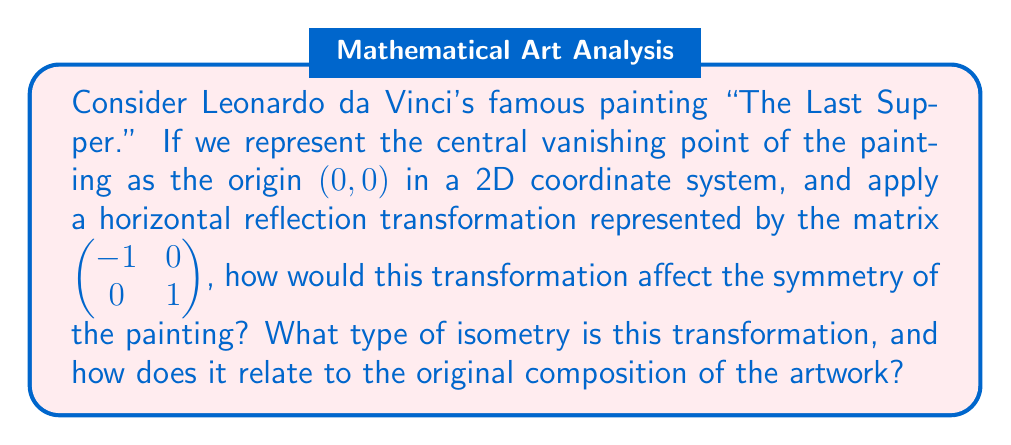Solve this math problem. To analyze this problem, let's break it down into steps:

1. Understanding the original symmetry:
   "The Last Supper" is known for its near-perfect bilateral symmetry, with Jesus at the center and the apostles arranged symmetrically on either side.

2. The transformation matrix:
   The given matrix $\begin{pmatrix} -1 & 0 \\ 0 & 1 \end{pmatrix}$ represents a horizontal reflection about the y-axis.

3. Effect of the transformation:
   - This transformation will flip the painting horizontally, effectively creating a mirror image.
   - The central vanishing point (0,0) remains unchanged.
   - Elements on the left side of the original painting will now be on the right, and vice versa.

4. Impact on symmetry:
   - The bilateral symmetry of the painting is preserved.
   - However, the specific arrangement of the apostles and other elements will be reversed.

5. Type of isometry:
   - This transformation is an isometry, as it preserves distances and angles.
   - Specifically, it is a reflection, which is a type of rigid transformation.

6. Relation to original composition:
   - The transformation highlights the intentional symmetry in da Vinci's composition.
   - It demonstrates how the painting would look if viewed in a mirror, emphasizing the balance and harmony of the original design.

In the context of art history, this transformation allows us to appreciate the careful planning and geometric precision that went into creating "The Last Supper." It showcases how mathematical concepts like linear transformations can be used to analyze and understand the structure of classical artworks.
Answer: The horizontal reflection transformation preserves the bilateral symmetry of "The Last Supper" while reversing the left-right arrangement of elements. This transformation is an isometry, specifically a reflection, which highlights the intentional symmetry in da Vinci's original composition by creating a mirror image of the painting. 